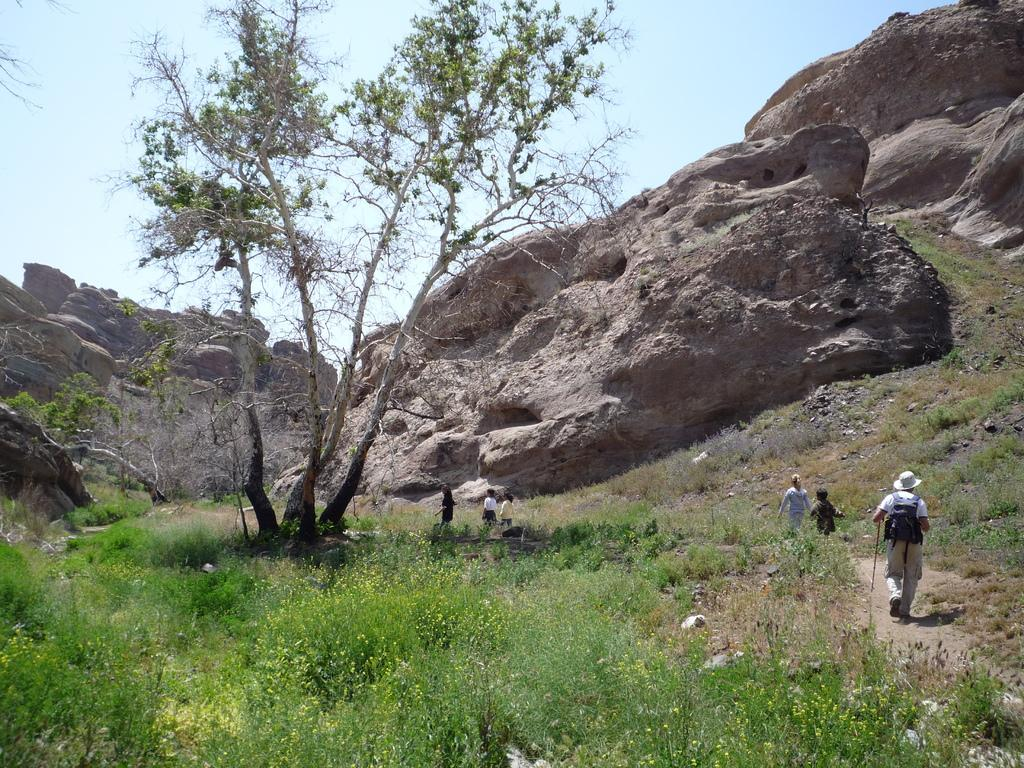What are the people in the image doing? The people in the image are walking. On what type of surface are the people walking? They are walking on a mud road. What geographical feature is visible in the image? There is a rock mountain in the image. What type of vegetation can be seen in the image? There are plants and a tree in the image. What type of farm can be seen in the image? There is no farm present in the image. What nerve is responsible for the sensation of walking in the image? The image is a visual representation and does not depict the human nervous system, so it is not possible to determine which nerve is responsible for the sensation of walking. 